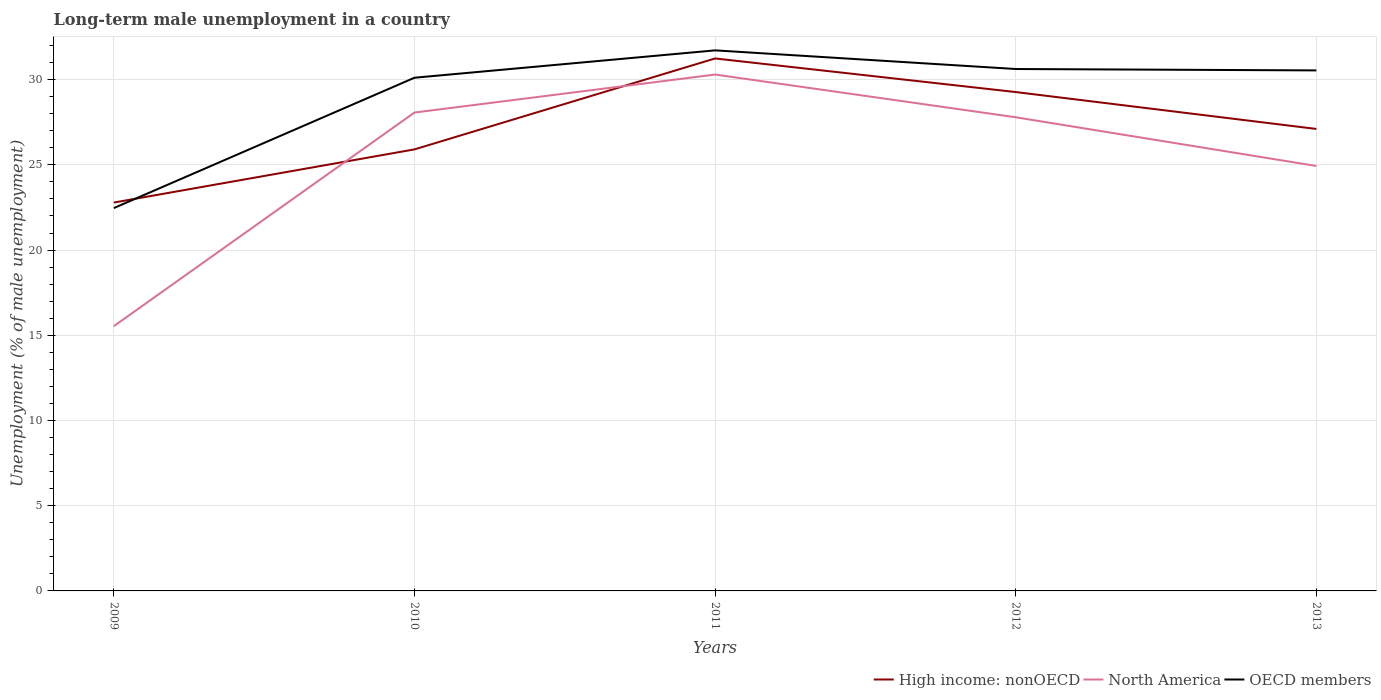Does the line corresponding to North America intersect with the line corresponding to OECD members?
Ensure brevity in your answer.  No. Is the number of lines equal to the number of legend labels?
Make the answer very short. Yes. Across all years, what is the maximum percentage of long-term unemployed male population in North America?
Offer a terse response. 15.54. What is the total percentage of long-term unemployed male population in High income: nonOECD in the graph?
Give a very brief answer. -5.34. What is the difference between the highest and the second highest percentage of long-term unemployed male population in OECD members?
Offer a very short reply. 9.25. What is the difference between two consecutive major ticks on the Y-axis?
Give a very brief answer. 5. Are the values on the major ticks of Y-axis written in scientific E-notation?
Make the answer very short. No. Does the graph contain any zero values?
Offer a very short reply. No. Where does the legend appear in the graph?
Provide a succinct answer. Bottom right. How are the legend labels stacked?
Provide a succinct answer. Horizontal. What is the title of the graph?
Make the answer very short. Long-term male unemployment in a country. Does "Middle East & North Africa (developing only)" appear as one of the legend labels in the graph?
Your response must be concise. No. What is the label or title of the X-axis?
Make the answer very short. Years. What is the label or title of the Y-axis?
Your response must be concise. Unemployment (% of male unemployment). What is the Unemployment (% of male unemployment) in High income: nonOECD in 2009?
Your answer should be compact. 22.79. What is the Unemployment (% of male unemployment) in North America in 2009?
Your response must be concise. 15.54. What is the Unemployment (% of male unemployment) of OECD members in 2009?
Provide a short and direct response. 22.46. What is the Unemployment (% of male unemployment) of High income: nonOECD in 2010?
Your answer should be very brief. 25.91. What is the Unemployment (% of male unemployment) of North America in 2010?
Ensure brevity in your answer.  28.07. What is the Unemployment (% of male unemployment) of OECD members in 2010?
Your answer should be very brief. 30.11. What is the Unemployment (% of male unemployment) of High income: nonOECD in 2011?
Provide a succinct answer. 31.24. What is the Unemployment (% of male unemployment) in North America in 2011?
Provide a short and direct response. 30.3. What is the Unemployment (% of male unemployment) in OECD members in 2011?
Your response must be concise. 31.72. What is the Unemployment (% of male unemployment) in High income: nonOECD in 2012?
Your answer should be compact. 29.27. What is the Unemployment (% of male unemployment) of North America in 2012?
Ensure brevity in your answer.  27.79. What is the Unemployment (% of male unemployment) in OECD members in 2012?
Make the answer very short. 30.62. What is the Unemployment (% of male unemployment) in High income: nonOECD in 2013?
Your answer should be very brief. 27.11. What is the Unemployment (% of male unemployment) of North America in 2013?
Your answer should be very brief. 24.93. What is the Unemployment (% of male unemployment) in OECD members in 2013?
Provide a succinct answer. 30.54. Across all years, what is the maximum Unemployment (% of male unemployment) in High income: nonOECD?
Your answer should be compact. 31.24. Across all years, what is the maximum Unemployment (% of male unemployment) in North America?
Offer a terse response. 30.3. Across all years, what is the maximum Unemployment (% of male unemployment) in OECD members?
Offer a very short reply. 31.72. Across all years, what is the minimum Unemployment (% of male unemployment) of High income: nonOECD?
Offer a terse response. 22.79. Across all years, what is the minimum Unemployment (% of male unemployment) of North America?
Provide a succinct answer. 15.54. Across all years, what is the minimum Unemployment (% of male unemployment) of OECD members?
Make the answer very short. 22.46. What is the total Unemployment (% of male unemployment) of High income: nonOECD in the graph?
Provide a succinct answer. 136.31. What is the total Unemployment (% of male unemployment) of North America in the graph?
Ensure brevity in your answer.  126.62. What is the total Unemployment (% of male unemployment) of OECD members in the graph?
Ensure brevity in your answer.  145.45. What is the difference between the Unemployment (% of male unemployment) in High income: nonOECD in 2009 and that in 2010?
Your answer should be compact. -3.12. What is the difference between the Unemployment (% of male unemployment) in North America in 2009 and that in 2010?
Offer a very short reply. -12.53. What is the difference between the Unemployment (% of male unemployment) in OECD members in 2009 and that in 2010?
Give a very brief answer. -7.65. What is the difference between the Unemployment (% of male unemployment) in High income: nonOECD in 2009 and that in 2011?
Offer a very short reply. -8.45. What is the difference between the Unemployment (% of male unemployment) of North America in 2009 and that in 2011?
Offer a very short reply. -14.76. What is the difference between the Unemployment (% of male unemployment) in OECD members in 2009 and that in 2011?
Your response must be concise. -9.25. What is the difference between the Unemployment (% of male unemployment) of High income: nonOECD in 2009 and that in 2012?
Provide a short and direct response. -6.48. What is the difference between the Unemployment (% of male unemployment) of North America in 2009 and that in 2012?
Make the answer very short. -12.26. What is the difference between the Unemployment (% of male unemployment) in OECD members in 2009 and that in 2012?
Ensure brevity in your answer.  -8.16. What is the difference between the Unemployment (% of male unemployment) in High income: nonOECD in 2009 and that in 2013?
Provide a short and direct response. -4.32. What is the difference between the Unemployment (% of male unemployment) in North America in 2009 and that in 2013?
Provide a short and direct response. -9.4. What is the difference between the Unemployment (% of male unemployment) in OECD members in 2009 and that in 2013?
Offer a terse response. -8.08. What is the difference between the Unemployment (% of male unemployment) of High income: nonOECD in 2010 and that in 2011?
Your answer should be compact. -5.34. What is the difference between the Unemployment (% of male unemployment) in North America in 2010 and that in 2011?
Your answer should be very brief. -2.23. What is the difference between the Unemployment (% of male unemployment) of OECD members in 2010 and that in 2011?
Make the answer very short. -1.61. What is the difference between the Unemployment (% of male unemployment) in High income: nonOECD in 2010 and that in 2012?
Ensure brevity in your answer.  -3.36. What is the difference between the Unemployment (% of male unemployment) in North America in 2010 and that in 2012?
Provide a short and direct response. 0.28. What is the difference between the Unemployment (% of male unemployment) in OECD members in 2010 and that in 2012?
Your answer should be compact. -0.51. What is the difference between the Unemployment (% of male unemployment) of High income: nonOECD in 2010 and that in 2013?
Offer a very short reply. -1.2. What is the difference between the Unemployment (% of male unemployment) of North America in 2010 and that in 2013?
Your answer should be very brief. 3.14. What is the difference between the Unemployment (% of male unemployment) in OECD members in 2010 and that in 2013?
Your response must be concise. -0.43. What is the difference between the Unemployment (% of male unemployment) in High income: nonOECD in 2011 and that in 2012?
Make the answer very short. 1.97. What is the difference between the Unemployment (% of male unemployment) of North America in 2011 and that in 2012?
Your answer should be compact. 2.51. What is the difference between the Unemployment (% of male unemployment) in OECD members in 2011 and that in 2012?
Offer a very short reply. 1.09. What is the difference between the Unemployment (% of male unemployment) of High income: nonOECD in 2011 and that in 2013?
Give a very brief answer. 4.14. What is the difference between the Unemployment (% of male unemployment) in North America in 2011 and that in 2013?
Offer a very short reply. 5.37. What is the difference between the Unemployment (% of male unemployment) in OECD members in 2011 and that in 2013?
Your answer should be very brief. 1.18. What is the difference between the Unemployment (% of male unemployment) in High income: nonOECD in 2012 and that in 2013?
Your answer should be compact. 2.16. What is the difference between the Unemployment (% of male unemployment) of North America in 2012 and that in 2013?
Give a very brief answer. 2.86. What is the difference between the Unemployment (% of male unemployment) of OECD members in 2012 and that in 2013?
Make the answer very short. 0.08. What is the difference between the Unemployment (% of male unemployment) in High income: nonOECD in 2009 and the Unemployment (% of male unemployment) in North America in 2010?
Ensure brevity in your answer.  -5.28. What is the difference between the Unemployment (% of male unemployment) of High income: nonOECD in 2009 and the Unemployment (% of male unemployment) of OECD members in 2010?
Offer a very short reply. -7.32. What is the difference between the Unemployment (% of male unemployment) in North America in 2009 and the Unemployment (% of male unemployment) in OECD members in 2010?
Keep it short and to the point. -14.58. What is the difference between the Unemployment (% of male unemployment) in High income: nonOECD in 2009 and the Unemployment (% of male unemployment) in North America in 2011?
Offer a very short reply. -7.51. What is the difference between the Unemployment (% of male unemployment) of High income: nonOECD in 2009 and the Unemployment (% of male unemployment) of OECD members in 2011?
Provide a short and direct response. -8.93. What is the difference between the Unemployment (% of male unemployment) in North America in 2009 and the Unemployment (% of male unemployment) in OECD members in 2011?
Offer a very short reply. -16.18. What is the difference between the Unemployment (% of male unemployment) in High income: nonOECD in 2009 and the Unemployment (% of male unemployment) in North America in 2012?
Offer a very short reply. -5. What is the difference between the Unemployment (% of male unemployment) of High income: nonOECD in 2009 and the Unemployment (% of male unemployment) of OECD members in 2012?
Ensure brevity in your answer.  -7.83. What is the difference between the Unemployment (% of male unemployment) in North America in 2009 and the Unemployment (% of male unemployment) in OECD members in 2012?
Make the answer very short. -15.09. What is the difference between the Unemployment (% of male unemployment) of High income: nonOECD in 2009 and the Unemployment (% of male unemployment) of North America in 2013?
Your answer should be compact. -2.14. What is the difference between the Unemployment (% of male unemployment) of High income: nonOECD in 2009 and the Unemployment (% of male unemployment) of OECD members in 2013?
Your answer should be very brief. -7.75. What is the difference between the Unemployment (% of male unemployment) in North America in 2009 and the Unemployment (% of male unemployment) in OECD members in 2013?
Provide a short and direct response. -15.01. What is the difference between the Unemployment (% of male unemployment) in High income: nonOECD in 2010 and the Unemployment (% of male unemployment) in North America in 2011?
Your answer should be compact. -4.39. What is the difference between the Unemployment (% of male unemployment) of High income: nonOECD in 2010 and the Unemployment (% of male unemployment) of OECD members in 2011?
Give a very brief answer. -5.81. What is the difference between the Unemployment (% of male unemployment) in North America in 2010 and the Unemployment (% of male unemployment) in OECD members in 2011?
Your response must be concise. -3.65. What is the difference between the Unemployment (% of male unemployment) of High income: nonOECD in 2010 and the Unemployment (% of male unemployment) of North America in 2012?
Ensure brevity in your answer.  -1.88. What is the difference between the Unemployment (% of male unemployment) in High income: nonOECD in 2010 and the Unemployment (% of male unemployment) in OECD members in 2012?
Provide a short and direct response. -4.72. What is the difference between the Unemployment (% of male unemployment) in North America in 2010 and the Unemployment (% of male unemployment) in OECD members in 2012?
Provide a short and direct response. -2.55. What is the difference between the Unemployment (% of male unemployment) of High income: nonOECD in 2010 and the Unemployment (% of male unemployment) of North America in 2013?
Provide a short and direct response. 0.97. What is the difference between the Unemployment (% of male unemployment) in High income: nonOECD in 2010 and the Unemployment (% of male unemployment) in OECD members in 2013?
Keep it short and to the point. -4.63. What is the difference between the Unemployment (% of male unemployment) in North America in 2010 and the Unemployment (% of male unemployment) in OECD members in 2013?
Offer a very short reply. -2.47. What is the difference between the Unemployment (% of male unemployment) in High income: nonOECD in 2011 and the Unemployment (% of male unemployment) in North America in 2012?
Give a very brief answer. 3.45. What is the difference between the Unemployment (% of male unemployment) of High income: nonOECD in 2011 and the Unemployment (% of male unemployment) of OECD members in 2012?
Keep it short and to the point. 0.62. What is the difference between the Unemployment (% of male unemployment) of North America in 2011 and the Unemployment (% of male unemployment) of OECD members in 2012?
Provide a short and direct response. -0.33. What is the difference between the Unemployment (% of male unemployment) of High income: nonOECD in 2011 and the Unemployment (% of male unemployment) of North America in 2013?
Offer a very short reply. 6.31. What is the difference between the Unemployment (% of male unemployment) in High income: nonOECD in 2011 and the Unemployment (% of male unemployment) in OECD members in 2013?
Make the answer very short. 0.7. What is the difference between the Unemployment (% of male unemployment) in North America in 2011 and the Unemployment (% of male unemployment) in OECD members in 2013?
Make the answer very short. -0.24. What is the difference between the Unemployment (% of male unemployment) in High income: nonOECD in 2012 and the Unemployment (% of male unemployment) in North America in 2013?
Provide a succinct answer. 4.34. What is the difference between the Unemployment (% of male unemployment) of High income: nonOECD in 2012 and the Unemployment (% of male unemployment) of OECD members in 2013?
Offer a very short reply. -1.27. What is the difference between the Unemployment (% of male unemployment) in North America in 2012 and the Unemployment (% of male unemployment) in OECD members in 2013?
Your answer should be compact. -2.75. What is the average Unemployment (% of male unemployment) of High income: nonOECD per year?
Your answer should be compact. 27.26. What is the average Unemployment (% of male unemployment) of North America per year?
Offer a very short reply. 25.32. What is the average Unemployment (% of male unemployment) of OECD members per year?
Your answer should be very brief. 29.09. In the year 2009, what is the difference between the Unemployment (% of male unemployment) in High income: nonOECD and Unemployment (% of male unemployment) in North America?
Your response must be concise. 7.25. In the year 2009, what is the difference between the Unemployment (% of male unemployment) in High income: nonOECD and Unemployment (% of male unemployment) in OECD members?
Offer a very short reply. 0.32. In the year 2009, what is the difference between the Unemployment (% of male unemployment) of North America and Unemployment (% of male unemployment) of OECD members?
Your answer should be very brief. -6.93. In the year 2010, what is the difference between the Unemployment (% of male unemployment) of High income: nonOECD and Unemployment (% of male unemployment) of North America?
Your answer should be very brief. -2.16. In the year 2010, what is the difference between the Unemployment (% of male unemployment) in High income: nonOECD and Unemployment (% of male unemployment) in OECD members?
Offer a very short reply. -4.21. In the year 2010, what is the difference between the Unemployment (% of male unemployment) in North America and Unemployment (% of male unemployment) in OECD members?
Make the answer very short. -2.04. In the year 2011, what is the difference between the Unemployment (% of male unemployment) of High income: nonOECD and Unemployment (% of male unemployment) of North America?
Ensure brevity in your answer.  0.94. In the year 2011, what is the difference between the Unemployment (% of male unemployment) in High income: nonOECD and Unemployment (% of male unemployment) in OECD members?
Your answer should be compact. -0.47. In the year 2011, what is the difference between the Unemployment (% of male unemployment) in North America and Unemployment (% of male unemployment) in OECD members?
Offer a very short reply. -1.42. In the year 2012, what is the difference between the Unemployment (% of male unemployment) of High income: nonOECD and Unemployment (% of male unemployment) of North America?
Keep it short and to the point. 1.48. In the year 2012, what is the difference between the Unemployment (% of male unemployment) of High income: nonOECD and Unemployment (% of male unemployment) of OECD members?
Provide a short and direct response. -1.35. In the year 2012, what is the difference between the Unemployment (% of male unemployment) in North America and Unemployment (% of male unemployment) in OECD members?
Your answer should be very brief. -2.83. In the year 2013, what is the difference between the Unemployment (% of male unemployment) in High income: nonOECD and Unemployment (% of male unemployment) in North America?
Offer a very short reply. 2.17. In the year 2013, what is the difference between the Unemployment (% of male unemployment) in High income: nonOECD and Unemployment (% of male unemployment) in OECD members?
Make the answer very short. -3.44. In the year 2013, what is the difference between the Unemployment (% of male unemployment) of North America and Unemployment (% of male unemployment) of OECD members?
Keep it short and to the point. -5.61. What is the ratio of the Unemployment (% of male unemployment) of High income: nonOECD in 2009 to that in 2010?
Your answer should be very brief. 0.88. What is the ratio of the Unemployment (% of male unemployment) of North America in 2009 to that in 2010?
Provide a succinct answer. 0.55. What is the ratio of the Unemployment (% of male unemployment) in OECD members in 2009 to that in 2010?
Provide a succinct answer. 0.75. What is the ratio of the Unemployment (% of male unemployment) in High income: nonOECD in 2009 to that in 2011?
Ensure brevity in your answer.  0.73. What is the ratio of the Unemployment (% of male unemployment) in North America in 2009 to that in 2011?
Your response must be concise. 0.51. What is the ratio of the Unemployment (% of male unemployment) of OECD members in 2009 to that in 2011?
Your response must be concise. 0.71. What is the ratio of the Unemployment (% of male unemployment) of High income: nonOECD in 2009 to that in 2012?
Provide a short and direct response. 0.78. What is the ratio of the Unemployment (% of male unemployment) of North America in 2009 to that in 2012?
Ensure brevity in your answer.  0.56. What is the ratio of the Unemployment (% of male unemployment) of OECD members in 2009 to that in 2012?
Your answer should be very brief. 0.73. What is the ratio of the Unemployment (% of male unemployment) in High income: nonOECD in 2009 to that in 2013?
Keep it short and to the point. 0.84. What is the ratio of the Unemployment (% of male unemployment) of North America in 2009 to that in 2013?
Your answer should be very brief. 0.62. What is the ratio of the Unemployment (% of male unemployment) of OECD members in 2009 to that in 2013?
Give a very brief answer. 0.74. What is the ratio of the Unemployment (% of male unemployment) of High income: nonOECD in 2010 to that in 2011?
Provide a short and direct response. 0.83. What is the ratio of the Unemployment (% of male unemployment) of North America in 2010 to that in 2011?
Your answer should be compact. 0.93. What is the ratio of the Unemployment (% of male unemployment) in OECD members in 2010 to that in 2011?
Keep it short and to the point. 0.95. What is the ratio of the Unemployment (% of male unemployment) in High income: nonOECD in 2010 to that in 2012?
Give a very brief answer. 0.89. What is the ratio of the Unemployment (% of male unemployment) of North America in 2010 to that in 2012?
Provide a succinct answer. 1.01. What is the ratio of the Unemployment (% of male unemployment) in OECD members in 2010 to that in 2012?
Offer a terse response. 0.98. What is the ratio of the Unemployment (% of male unemployment) of High income: nonOECD in 2010 to that in 2013?
Your answer should be very brief. 0.96. What is the ratio of the Unemployment (% of male unemployment) of North America in 2010 to that in 2013?
Give a very brief answer. 1.13. What is the ratio of the Unemployment (% of male unemployment) in OECD members in 2010 to that in 2013?
Give a very brief answer. 0.99. What is the ratio of the Unemployment (% of male unemployment) in High income: nonOECD in 2011 to that in 2012?
Your response must be concise. 1.07. What is the ratio of the Unemployment (% of male unemployment) in North America in 2011 to that in 2012?
Provide a short and direct response. 1.09. What is the ratio of the Unemployment (% of male unemployment) in OECD members in 2011 to that in 2012?
Offer a very short reply. 1.04. What is the ratio of the Unemployment (% of male unemployment) in High income: nonOECD in 2011 to that in 2013?
Your response must be concise. 1.15. What is the ratio of the Unemployment (% of male unemployment) in North America in 2011 to that in 2013?
Offer a terse response. 1.22. What is the ratio of the Unemployment (% of male unemployment) of High income: nonOECD in 2012 to that in 2013?
Offer a terse response. 1.08. What is the ratio of the Unemployment (% of male unemployment) in North America in 2012 to that in 2013?
Give a very brief answer. 1.11. What is the ratio of the Unemployment (% of male unemployment) of OECD members in 2012 to that in 2013?
Your response must be concise. 1. What is the difference between the highest and the second highest Unemployment (% of male unemployment) of High income: nonOECD?
Ensure brevity in your answer.  1.97. What is the difference between the highest and the second highest Unemployment (% of male unemployment) of North America?
Provide a succinct answer. 2.23. What is the difference between the highest and the second highest Unemployment (% of male unemployment) of OECD members?
Keep it short and to the point. 1.09. What is the difference between the highest and the lowest Unemployment (% of male unemployment) of High income: nonOECD?
Provide a short and direct response. 8.45. What is the difference between the highest and the lowest Unemployment (% of male unemployment) of North America?
Give a very brief answer. 14.76. What is the difference between the highest and the lowest Unemployment (% of male unemployment) in OECD members?
Provide a succinct answer. 9.25. 